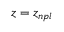<formula> <loc_0><loc_0><loc_500><loc_500>z = z _ { n p l }</formula> 